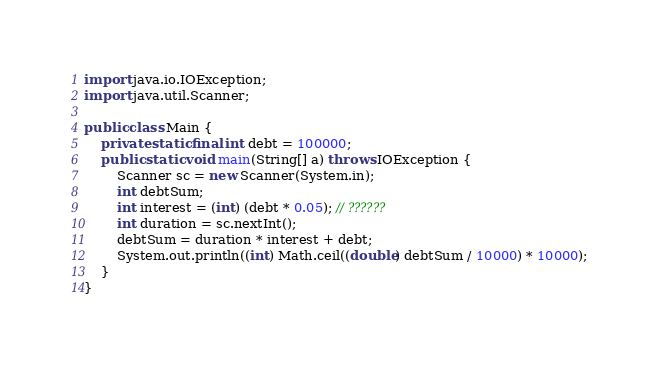<code> <loc_0><loc_0><loc_500><loc_500><_Java_>import java.io.IOException;
import java.util.Scanner;

public class Main {
	private static final int debt = 100000;
	public static void main(String[] a) throws IOException {
		Scanner sc = new Scanner(System.in);
		int debtSum;
		int interest = (int) (debt * 0.05); // ??????
		int duration = sc.nextInt();
		debtSum = duration * interest + debt;
		System.out.println((int) Math.ceil((double) debtSum / 10000) * 10000);
	}
}</code> 